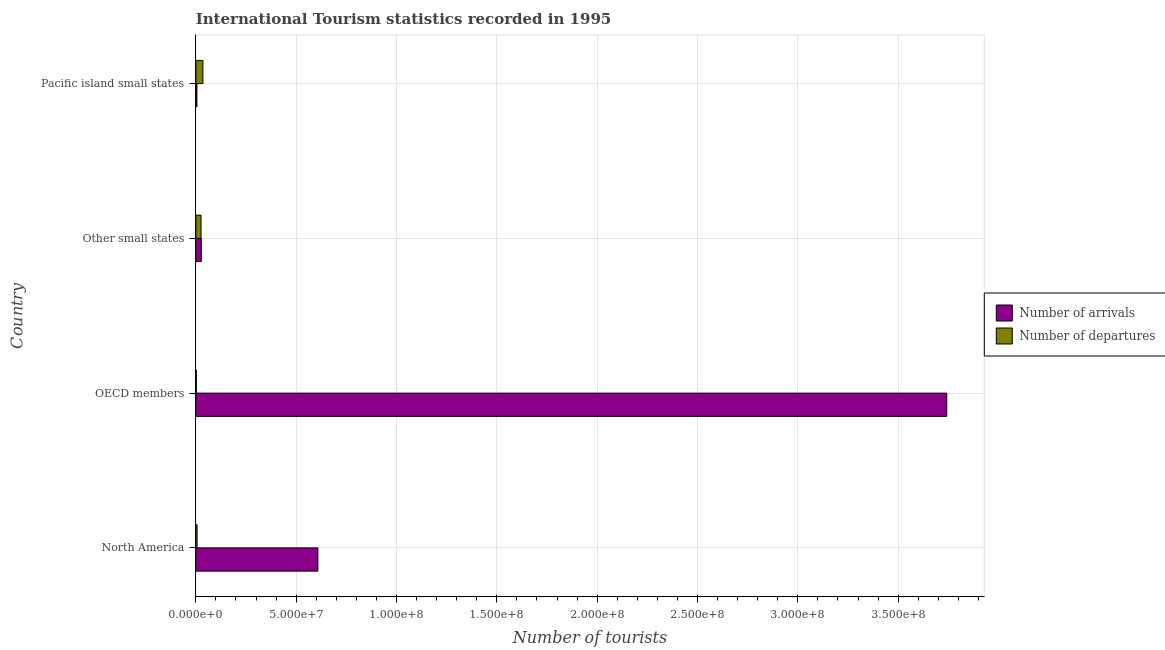How many groups of bars are there?
Your response must be concise. 4. Are the number of bars per tick equal to the number of legend labels?
Your answer should be compact. Yes. Are the number of bars on each tick of the Y-axis equal?
Make the answer very short. Yes. What is the label of the 2nd group of bars from the top?
Give a very brief answer. Other small states. In how many cases, is the number of bars for a given country not equal to the number of legend labels?
Your answer should be compact. 0. What is the number of tourist arrivals in Other small states?
Offer a very short reply. 2.73e+06. Across all countries, what is the maximum number of tourist arrivals?
Make the answer very short. 3.74e+08. Across all countries, what is the minimum number of tourist departures?
Your answer should be very brief. 2.49e+05. In which country was the number of tourist departures maximum?
Make the answer very short. Pacific island small states. In which country was the number of tourist arrivals minimum?
Give a very brief answer. Pacific island small states. What is the total number of tourist departures in the graph?
Ensure brevity in your answer.  7.00e+06. What is the difference between the number of tourist departures in North America and that in OECD members?
Offer a very short reply. 3.77e+05. What is the difference between the number of tourist departures in North America and the number of tourist arrivals in Other small states?
Your answer should be very brief. -2.11e+06. What is the average number of tourist arrivals per country?
Make the answer very short. 1.10e+08. What is the difference between the number of tourist departures and number of tourist arrivals in OECD members?
Provide a short and direct response. -3.74e+08. In how many countries, is the number of tourist arrivals greater than 170000000 ?
Provide a succinct answer. 1. What is the ratio of the number of tourist arrivals in Other small states to that in Pacific island small states?
Offer a terse response. 5.04. What is the difference between the highest and the second highest number of tourist arrivals?
Your response must be concise. 3.13e+08. What is the difference between the highest and the lowest number of tourist departures?
Give a very brief answer. 3.28e+06. Is the sum of the number of tourist departures in Other small states and Pacific island small states greater than the maximum number of tourist arrivals across all countries?
Give a very brief answer. No. What does the 1st bar from the top in Pacific island small states represents?
Provide a succinct answer. Number of departures. What does the 2nd bar from the bottom in Other small states represents?
Provide a succinct answer. Number of departures. Are all the bars in the graph horizontal?
Provide a succinct answer. Yes. How many countries are there in the graph?
Your answer should be very brief. 4. What is the difference between two consecutive major ticks on the X-axis?
Offer a very short reply. 5.00e+07. Are the values on the major ticks of X-axis written in scientific E-notation?
Your answer should be very brief. Yes. Does the graph contain grids?
Provide a short and direct response. Yes. Where does the legend appear in the graph?
Give a very brief answer. Center right. How many legend labels are there?
Make the answer very short. 2. What is the title of the graph?
Provide a succinct answer. International Tourism statistics recorded in 1995. Does "Urban Population" appear as one of the legend labels in the graph?
Provide a succinct answer. No. What is the label or title of the X-axis?
Give a very brief answer. Number of tourists. What is the Number of tourists of Number of arrivals in North America?
Ensure brevity in your answer.  6.08e+07. What is the Number of tourists of Number of departures in North America?
Your response must be concise. 6.26e+05. What is the Number of tourists of Number of arrivals in OECD members?
Your response must be concise. 3.74e+08. What is the Number of tourists in Number of departures in OECD members?
Keep it short and to the point. 2.49e+05. What is the Number of tourists of Number of arrivals in Other small states?
Provide a succinct answer. 2.73e+06. What is the Number of tourists of Number of departures in Other small states?
Offer a terse response. 2.60e+06. What is the Number of tourists of Number of arrivals in Pacific island small states?
Provide a succinct answer. 5.43e+05. What is the Number of tourists of Number of departures in Pacific island small states?
Ensure brevity in your answer.  3.52e+06. Across all countries, what is the maximum Number of tourists in Number of arrivals?
Your answer should be compact. 3.74e+08. Across all countries, what is the maximum Number of tourists of Number of departures?
Your answer should be compact. 3.52e+06. Across all countries, what is the minimum Number of tourists of Number of arrivals?
Your answer should be compact. 5.43e+05. Across all countries, what is the minimum Number of tourists of Number of departures?
Give a very brief answer. 2.49e+05. What is the total Number of tourists of Number of arrivals in the graph?
Make the answer very short. 4.38e+08. What is the total Number of tourists in Number of departures in the graph?
Provide a short and direct response. 7.00e+06. What is the difference between the Number of tourists in Number of arrivals in North America and that in OECD members?
Ensure brevity in your answer.  -3.13e+08. What is the difference between the Number of tourists of Number of departures in North America and that in OECD members?
Make the answer very short. 3.77e+05. What is the difference between the Number of tourists in Number of arrivals in North America and that in Other small states?
Ensure brevity in your answer.  5.81e+07. What is the difference between the Number of tourists in Number of departures in North America and that in Other small states?
Keep it short and to the point. -1.97e+06. What is the difference between the Number of tourists in Number of arrivals in North America and that in Pacific island small states?
Keep it short and to the point. 6.03e+07. What is the difference between the Number of tourists in Number of departures in North America and that in Pacific island small states?
Offer a terse response. -2.90e+06. What is the difference between the Number of tourists in Number of arrivals in OECD members and that in Other small states?
Keep it short and to the point. 3.71e+08. What is the difference between the Number of tourists of Number of departures in OECD members and that in Other small states?
Make the answer very short. -2.35e+06. What is the difference between the Number of tourists of Number of arrivals in OECD members and that in Pacific island small states?
Give a very brief answer. 3.74e+08. What is the difference between the Number of tourists in Number of departures in OECD members and that in Pacific island small states?
Provide a succinct answer. -3.28e+06. What is the difference between the Number of tourists in Number of arrivals in Other small states and that in Pacific island small states?
Make the answer very short. 2.19e+06. What is the difference between the Number of tourists of Number of departures in Other small states and that in Pacific island small states?
Provide a succinct answer. -9.24e+05. What is the difference between the Number of tourists in Number of arrivals in North America and the Number of tourists in Number of departures in OECD members?
Provide a short and direct response. 6.06e+07. What is the difference between the Number of tourists in Number of arrivals in North America and the Number of tourists in Number of departures in Other small states?
Offer a terse response. 5.82e+07. What is the difference between the Number of tourists in Number of arrivals in North America and the Number of tourists in Number of departures in Pacific island small states?
Provide a short and direct response. 5.73e+07. What is the difference between the Number of tourists in Number of arrivals in OECD members and the Number of tourists in Number of departures in Other small states?
Ensure brevity in your answer.  3.72e+08. What is the difference between the Number of tourists of Number of arrivals in OECD members and the Number of tourists of Number of departures in Pacific island small states?
Give a very brief answer. 3.71e+08. What is the difference between the Number of tourists in Number of arrivals in Other small states and the Number of tourists in Number of departures in Pacific island small states?
Ensure brevity in your answer.  -7.90e+05. What is the average Number of tourists of Number of arrivals per country?
Offer a very short reply. 1.10e+08. What is the average Number of tourists in Number of departures per country?
Make the answer very short. 1.75e+06. What is the difference between the Number of tourists of Number of arrivals and Number of tourists of Number of departures in North America?
Make the answer very short. 6.02e+07. What is the difference between the Number of tourists of Number of arrivals and Number of tourists of Number of departures in OECD members?
Ensure brevity in your answer.  3.74e+08. What is the difference between the Number of tourists of Number of arrivals and Number of tourists of Number of departures in Other small states?
Your answer should be very brief. 1.34e+05. What is the difference between the Number of tourists in Number of arrivals and Number of tourists in Number of departures in Pacific island small states?
Give a very brief answer. -2.98e+06. What is the ratio of the Number of tourists in Number of arrivals in North America to that in OECD members?
Keep it short and to the point. 0.16. What is the ratio of the Number of tourists in Number of departures in North America to that in OECD members?
Your response must be concise. 2.51. What is the ratio of the Number of tourists of Number of arrivals in North America to that in Other small states?
Make the answer very short. 22.24. What is the ratio of the Number of tourists of Number of departures in North America to that in Other small states?
Your response must be concise. 0.24. What is the ratio of the Number of tourists of Number of arrivals in North America to that in Pacific island small states?
Your answer should be compact. 112.01. What is the ratio of the Number of tourists in Number of departures in North America to that in Pacific island small states?
Provide a short and direct response. 0.18. What is the ratio of the Number of tourists in Number of arrivals in OECD members to that in Other small states?
Offer a very short reply. 136.85. What is the ratio of the Number of tourists in Number of departures in OECD members to that in Other small states?
Provide a short and direct response. 0.1. What is the ratio of the Number of tourists in Number of arrivals in OECD members to that in Pacific island small states?
Your answer should be very brief. 689.26. What is the ratio of the Number of tourists of Number of departures in OECD members to that in Pacific island small states?
Your response must be concise. 0.07. What is the ratio of the Number of tourists of Number of arrivals in Other small states to that in Pacific island small states?
Provide a succinct answer. 5.04. What is the ratio of the Number of tourists of Number of departures in Other small states to that in Pacific island small states?
Your response must be concise. 0.74. What is the difference between the highest and the second highest Number of tourists in Number of arrivals?
Provide a succinct answer. 3.13e+08. What is the difference between the highest and the second highest Number of tourists of Number of departures?
Your response must be concise. 9.24e+05. What is the difference between the highest and the lowest Number of tourists of Number of arrivals?
Your response must be concise. 3.74e+08. What is the difference between the highest and the lowest Number of tourists of Number of departures?
Give a very brief answer. 3.28e+06. 